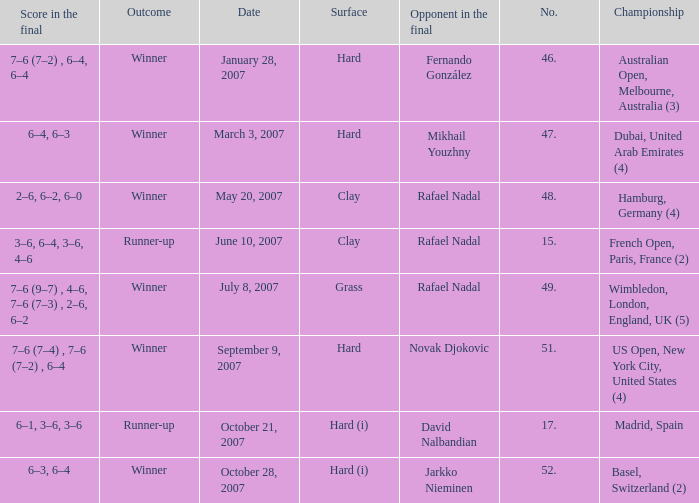The score in the final is 2–6, 6–2, 6–0, on what surface? Clay. 